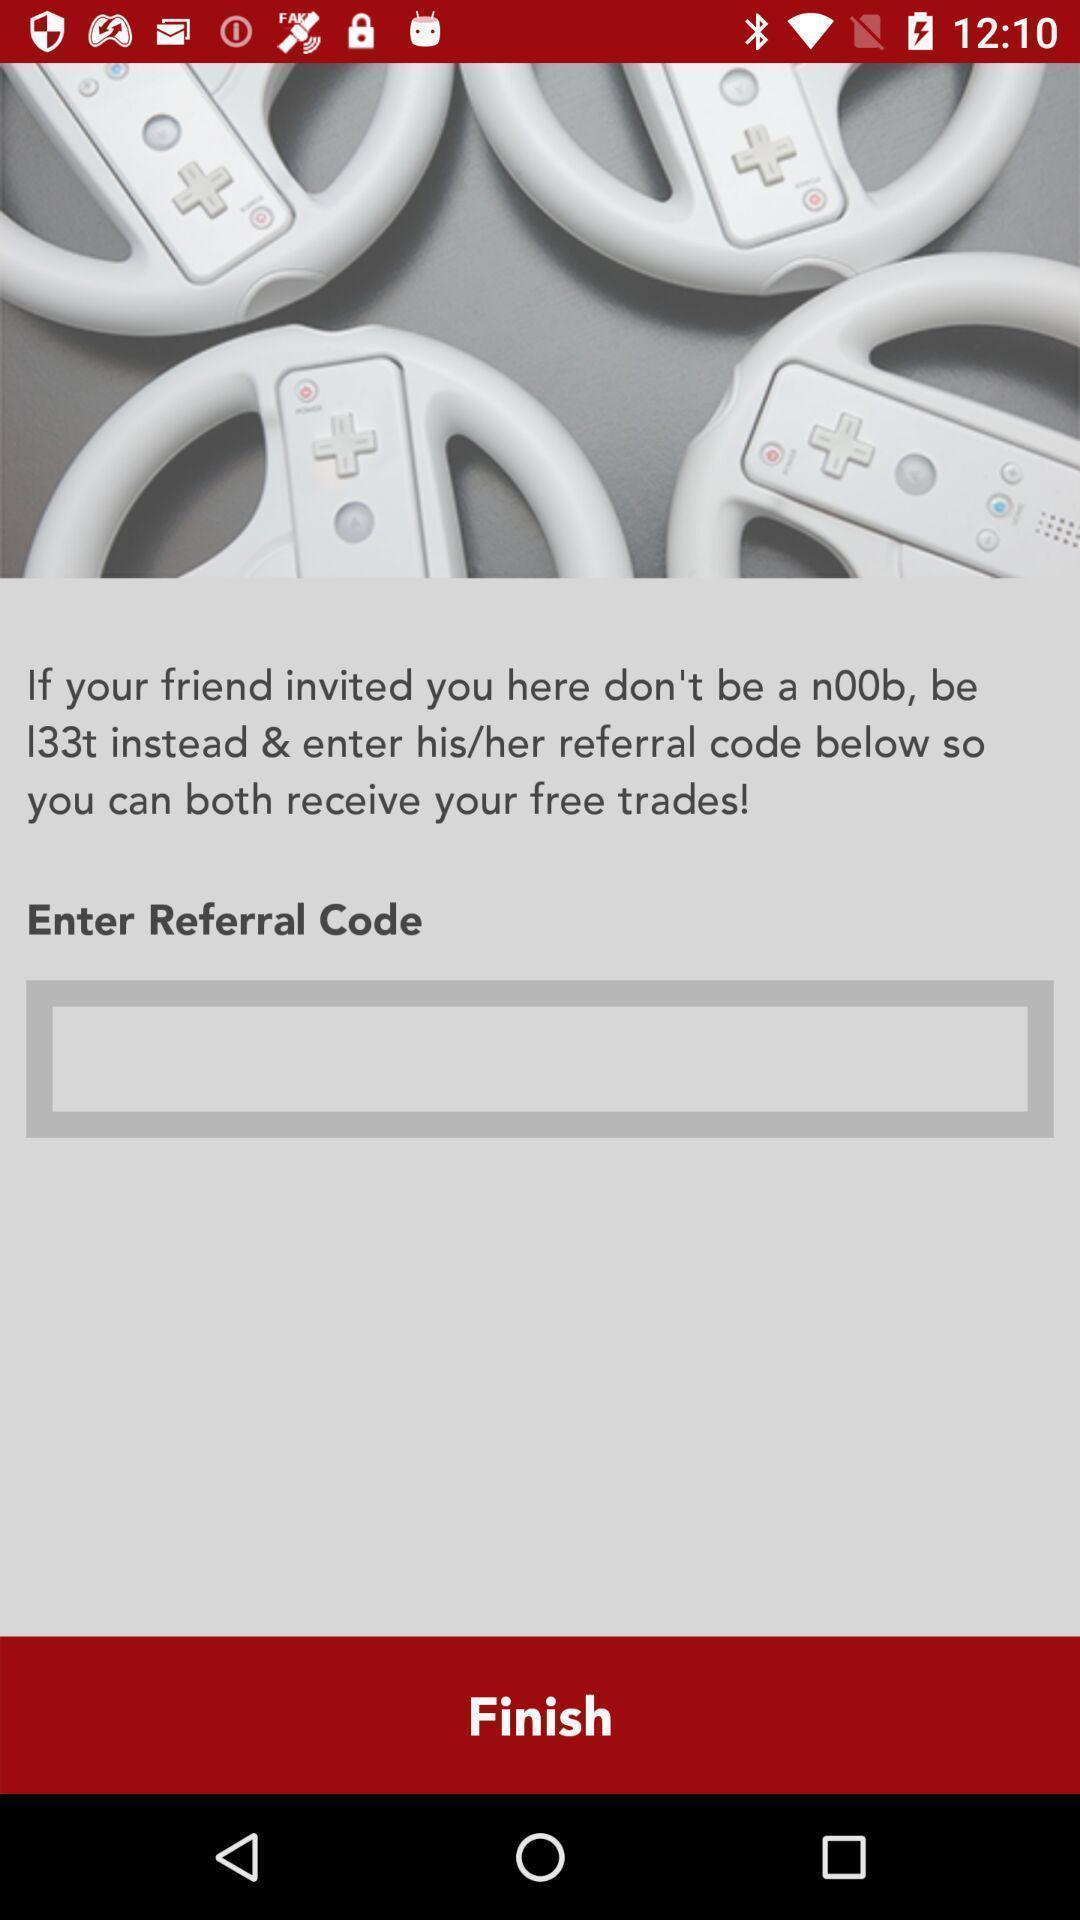Summarize the information in this screenshot. Text box to enter the referral code in the application. 